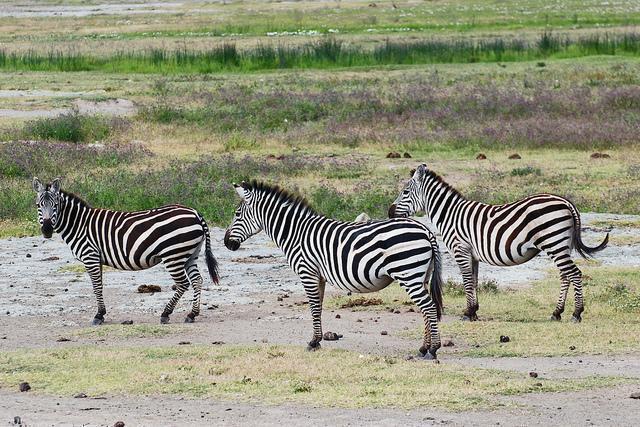What word shares the same first letter as the name of these animals?
Indicate the correct response by choosing from the four available options to answer the question.
Options: Carrot, zipper, baby, deep. Zipper. 